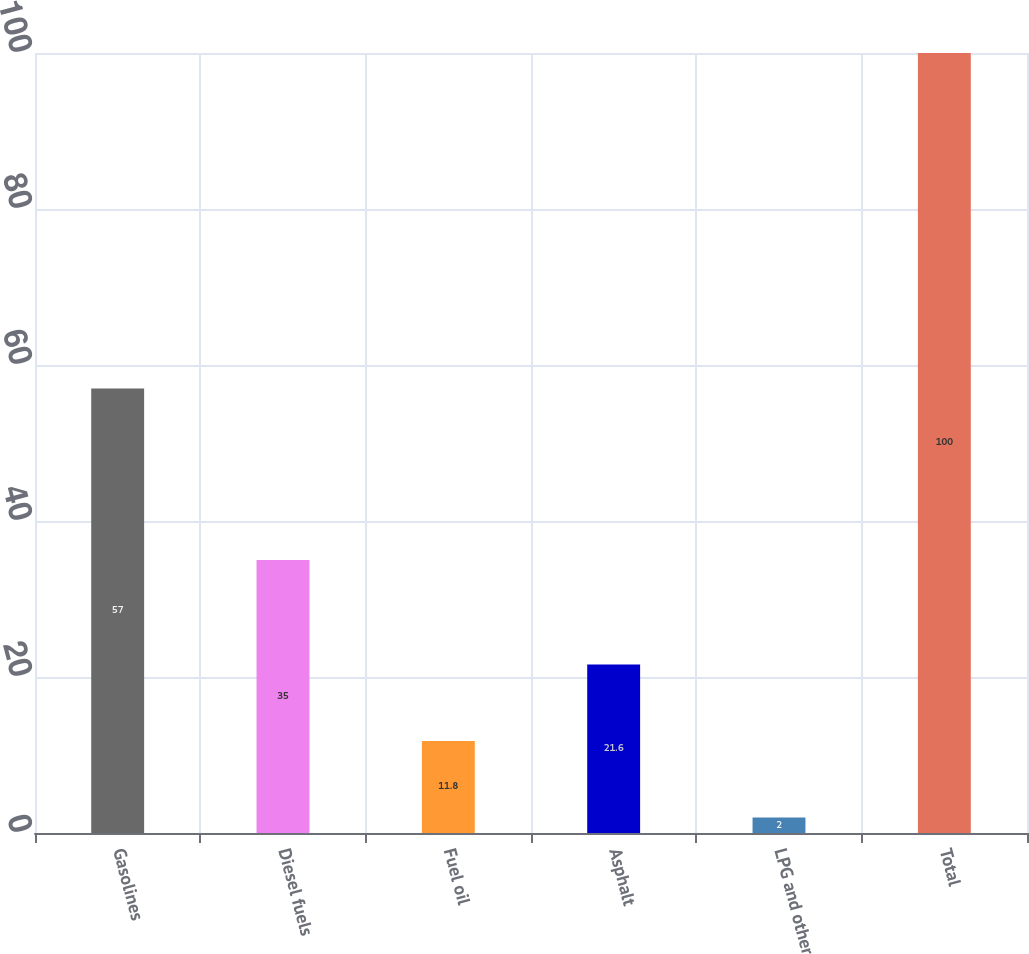<chart> <loc_0><loc_0><loc_500><loc_500><bar_chart><fcel>Gasolines<fcel>Diesel fuels<fcel>Fuel oil<fcel>Asphalt<fcel>LPG and other<fcel>Total<nl><fcel>57<fcel>35<fcel>11.8<fcel>21.6<fcel>2<fcel>100<nl></chart> 